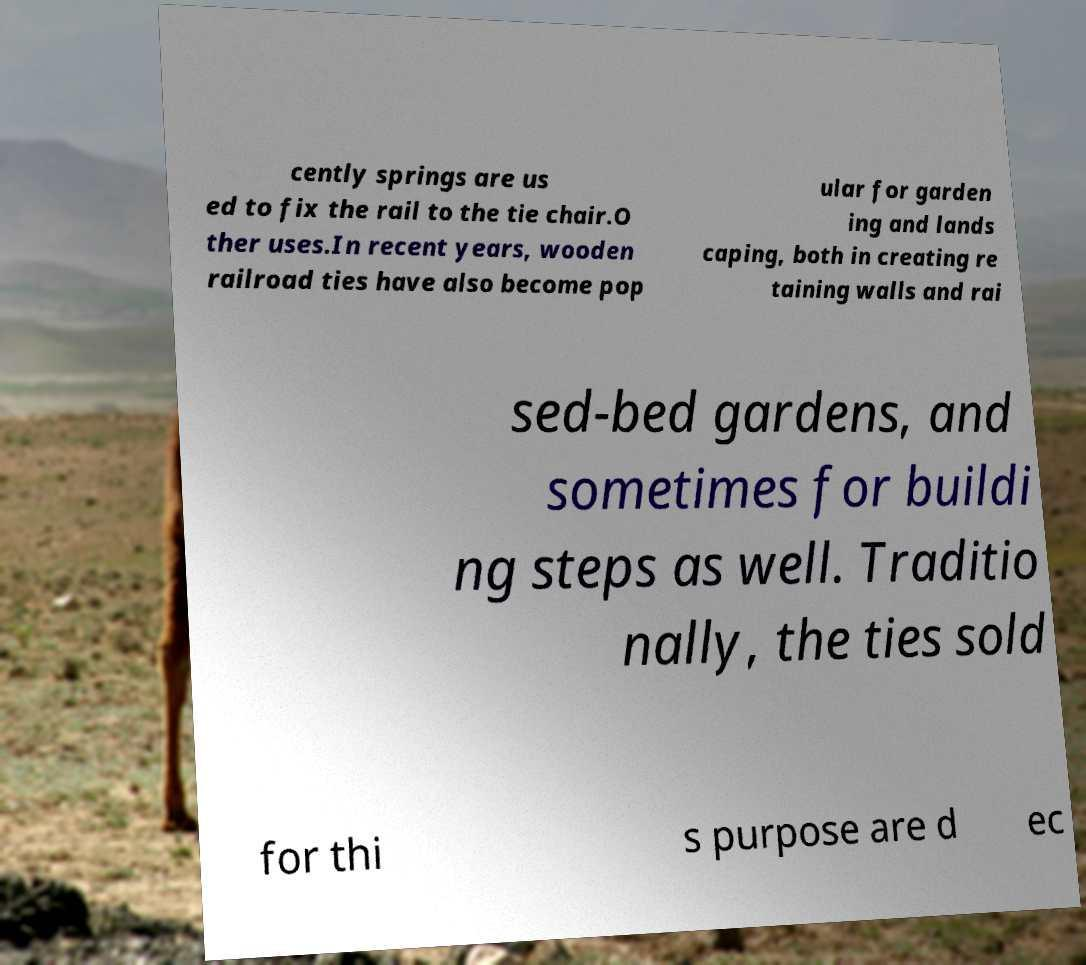What messages or text are displayed in this image? I need them in a readable, typed format. cently springs are us ed to fix the rail to the tie chair.O ther uses.In recent years, wooden railroad ties have also become pop ular for garden ing and lands caping, both in creating re taining walls and rai sed-bed gardens, and sometimes for buildi ng steps as well. Traditio nally, the ties sold for thi s purpose are d ec 